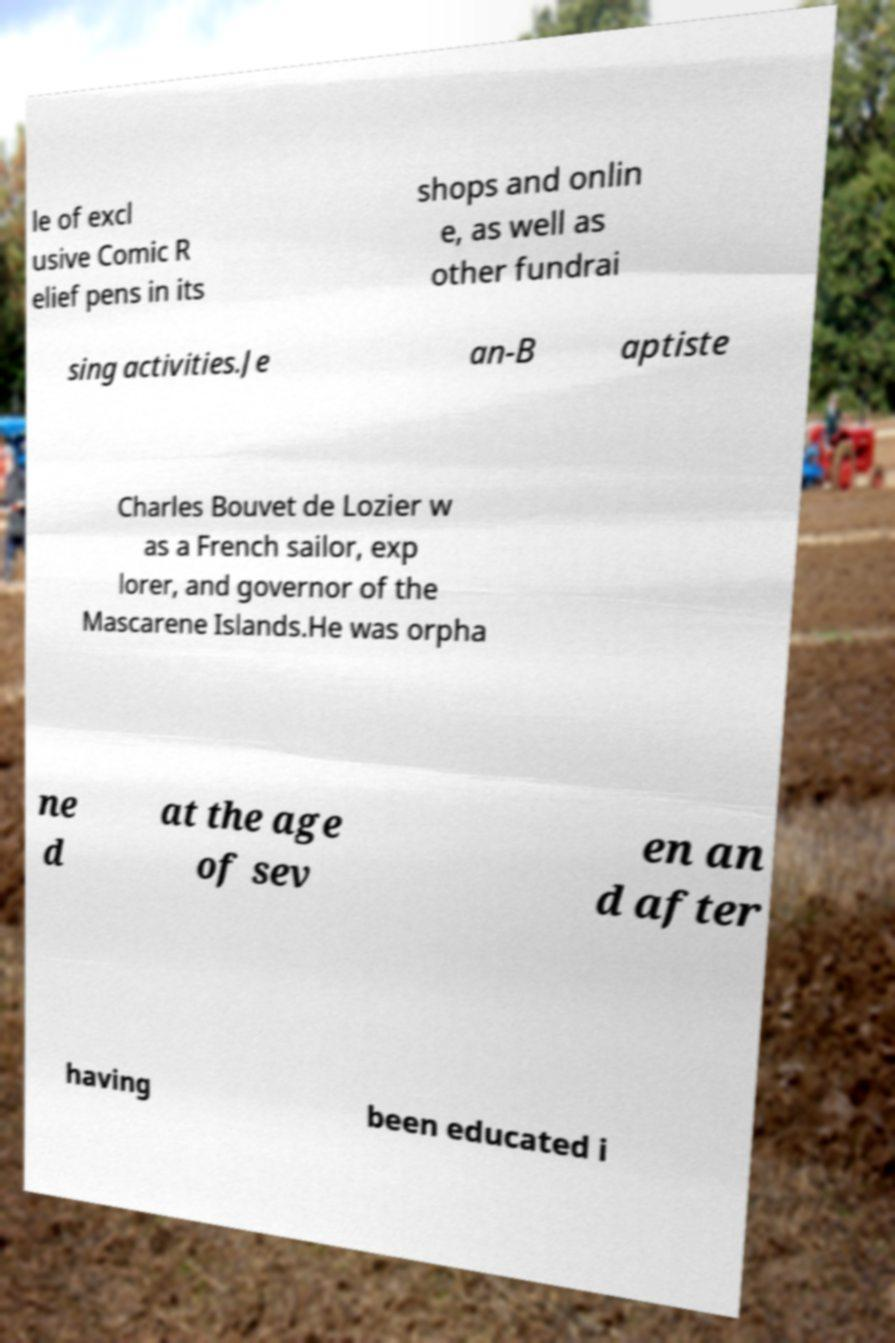I need the written content from this picture converted into text. Can you do that? le of excl usive Comic R elief pens in its shops and onlin e, as well as other fundrai sing activities.Je an-B aptiste Charles Bouvet de Lozier w as a French sailor, exp lorer, and governor of the Mascarene Islands.He was orpha ne d at the age of sev en an d after having been educated i 